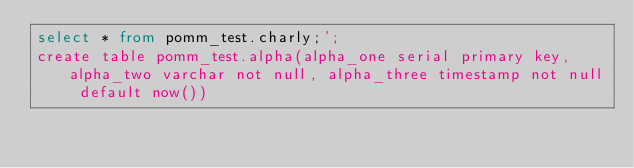<code> <loc_0><loc_0><loc_500><loc_500><_SQL_>select * from pomm_test.charly;';
create table pomm_test.alpha(alpha_one serial primary key, alpha_two varchar not null, alpha_three timestamp not null default now())
</code> 